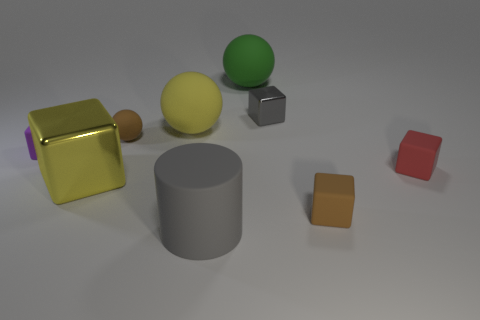Subtract all small matte blocks. How many blocks are left? 2 Subtract all yellow balls. How many balls are left? 2 Subtract all cylinders. How many objects are left? 8 Subtract 1 balls. How many balls are left? 2 Add 6 big red metallic blocks. How many big red metallic blocks exist? 6 Subtract 0 purple cylinders. How many objects are left? 9 Subtract all blue cylinders. Subtract all blue blocks. How many cylinders are left? 1 Subtract all large yellow metallic cubes. Subtract all big balls. How many objects are left? 6 Add 6 big metal objects. How many big metal objects are left? 7 